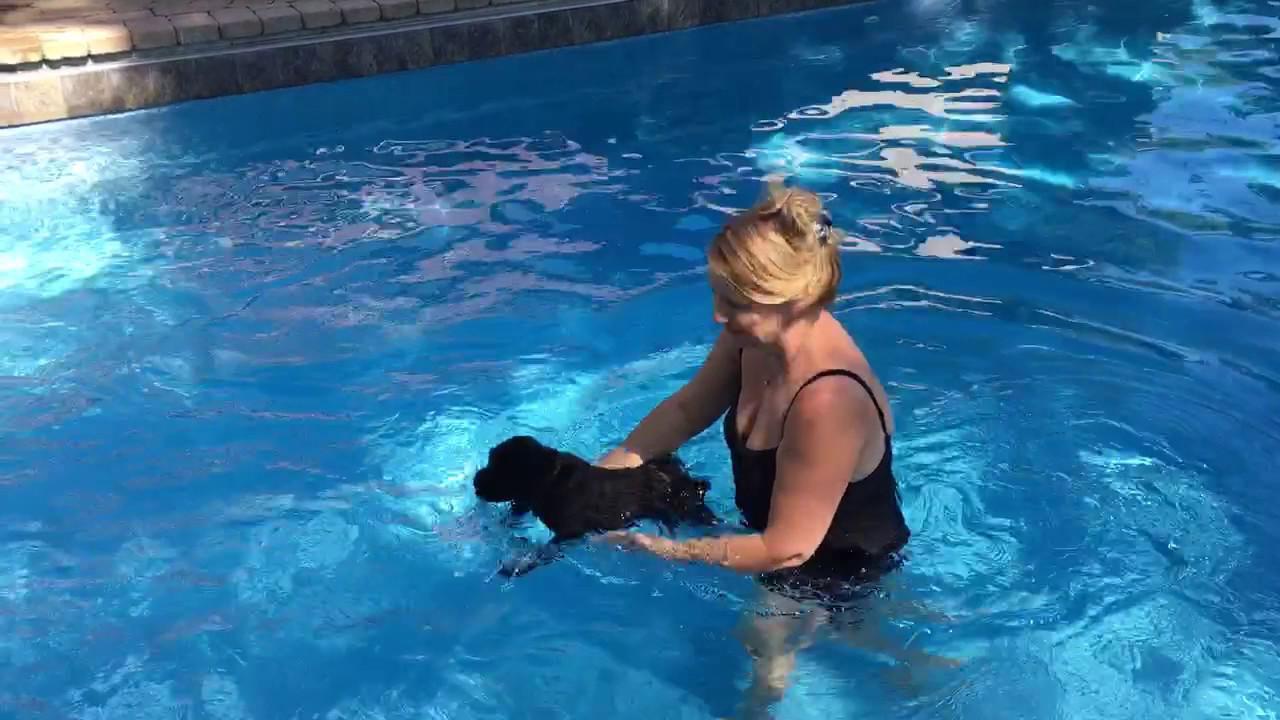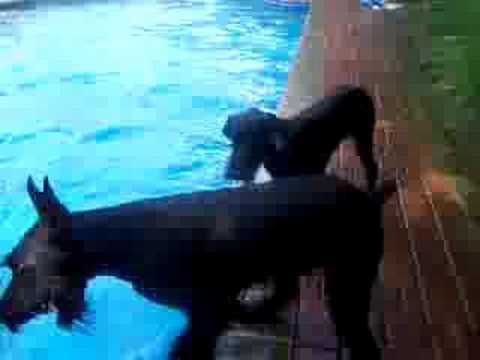The first image is the image on the left, the second image is the image on the right. Analyze the images presented: Is the assertion "Exactly one dog is partly in the water." valid? Answer yes or no. Yes. The first image is the image on the left, the second image is the image on the right. Given the left and right images, does the statement "two dogs are on the side of the pool looking at the water" hold true? Answer yes or no. Yes. 